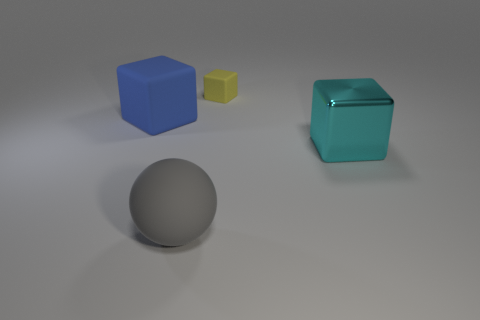Subtract all yellow rubber cubes. How many cubes are left? 2 Subtract all cyan cubes. How many cubes are left? 2 Subtract 1 cubes. How many cubes are left? 2 Subtract all cubes. How many objects are left? 1 Add 2 blue matte cubes. How many objects exist? 6 Subtract all green balls. How many yellow blocks are left? 1 Subtract all brown balls. Subtract all blue cylinders. How many balls are left? 1 Subtract all big objects. Subtract all metallic cubes. How many objects are left? 0 Add 1 large gray rubber balls. How many large gray rubber balls are left? 2 Add 4 blue matte things. How many blue matte things exist? 5 